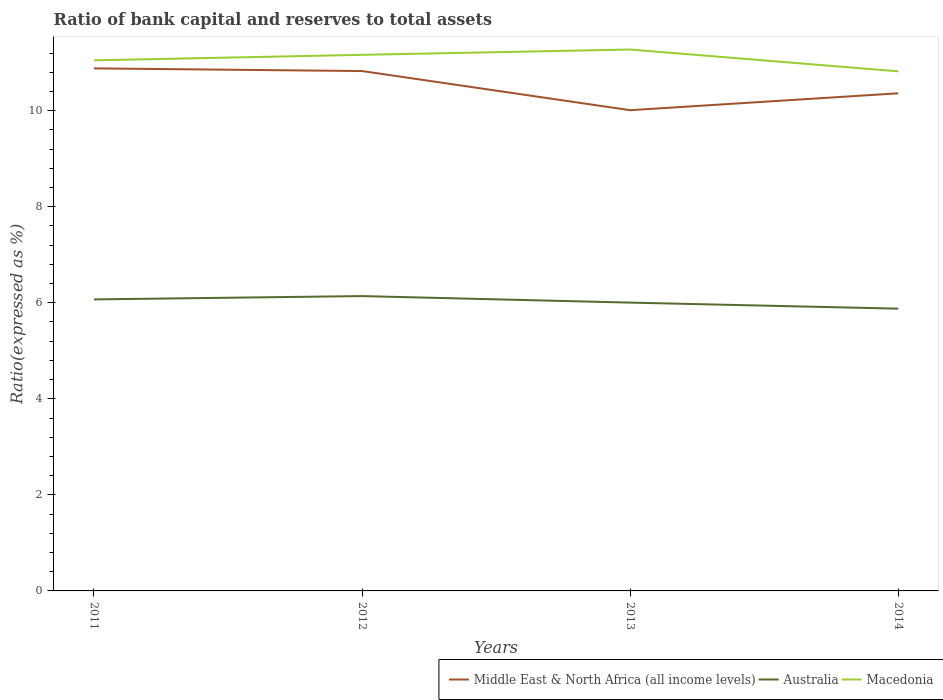How many different coloured lines are there?
Your answer should be compact. 3. Across all years, what is the maximum ratio of bank capital and reserves to total assets in Macedonia?
Offer a terse response. 10.82. In which year was the ratio of bank capital and reserves to total assets in Middle East & North Africa (all income levels) maximum?
Keep it short and to the point. 2013. What is the total ratio of bank capital and reserves to total assets in Australia in the graph?
Ensure brevity in your answer.  0.26. What is the difference between the highest and the second highest ratio of bank capital and reserves to total assets in Macedonia?
Keep it short and to the point. 0.45. How many lines are there?
Your answer should be compact. 3. How many years are there in the graph?
Ensure brevity in your answer.  4. What is the difference between two consecutive major ticks on the Y-axis?
Offer a terse response. 2. Where does the legend appear in the graph?
Ensure brevity in your answer.  Bottom right. How many legend labels are there?
Give a very brief answer. 3. How are the legend labels stacked?
Offer a terse response. Horizontal. What is the title of the graph?
Give a very brief answer. Ratio of bank capital and reserves to total assets. Does "Burundi" appear as one of the legend labels in the graph?
Your response must be concise. No. What is the label or title of the Y-axis?
Your response must be concise. Ratio(expressed as %). What is the Ratio(expressed as %) of Middle East & North Africa (all income levels) in 2011?
Provide a succinct answer. 10.88. What is the Ratio(expressed as %) of Australia in 2011?
Give a very brief answer. 6.07. What is the Ratio(expressed as %) of Macedonia in 2011?
Ensure brevity in your answer.  11.05. What is the Ratio(expressed as %) of Middle East & North Africa (all income levels) in 2012?
Your answer should be compact. 10.83. What is the Ratio(expressed as %) in Australia in 2012?
Ensure brevity in your answer.  6.14. What is the Ratio(expressed as %) in Macedonia in 2012?
Your answer should be compact. 11.16. What is the Ratio(expressed as %) in Middle East & North Africa (all income levels) in 2013?
Your answer should be very brief. 10.01. What is the Ratio(expressed as %) of Australia in 2013?
Your answer should be very brief. 6. What is the Ratio(expressed as %) in Macedonia in 2013?
Your answer should be very brief. 11.27. What is the Ratio(expressed as %) in Middle East & North Africa (all income levels) in 2014?
Ensure brevity in your answer.  10.36. What is the Ratio(expressed as %) in Australia in 2014?
Make the answer very short. 5.88. What is the Ratio(expressed as %) of Macedonia in 2014?
Provide a short and direct response. 10.82. Across all years, what is the maximum Ratio(expressed as %) in Middle East & North Africa (all income levels)?
Give a very brief answer. 10.88. Across all years, what is the maximum Ratio(expressed as %) of Australia?
Ensure brevity in your answer.  6.14. Across all years, what is the maximum Ratio(expressed as %) in Macedonia?
Ensure brevity in your answer.  11.27. Across all years, what is the minimum Ratio(expressed as %) in Middle East & North Africa (all income levels)?
Keep it short and to the point. 10.01. Across all years, what is the minimum Ratio(expressed as %) of Australia?
Your response must be concise. 5.88. Across all years, what is the minimum Ratio(expressed as %) in Macedonia?
Give a very brief answer. 10.82. What is the total Ratio(expressed as %) of Middle East & North Africa (all income levels) in the graph?
Your answer should be very brief. 42.08. What is the total Ratio(expressed as %) of Australia in the graph?
Offer a very short reply. 24.09. What is the total Ratio(expressed as %) of Macedonia in the graph?
Offer a terse response. 44.31. What is the difference between the Ratio(expressed as %) in Middle East & North Africa (all income levels) in 2011 and that in 2012?
Provide a succinct answer. 0.06. What is the difference between the Ratio(expressed as %) in Australia in 2011 and that in 2012?
Your answer should be compact. -0.07. What is the difference between the Ratio(expressed as %) in Macedonia in 2011 and that in 2012?
Offer a terse response. -0.12. What is the difference between the Ratio(expressed as %) in Middle East & North Africa (all income levels) in 2011 and that in 2013?
Offer a very short reply. 0.87. What is the difference between the Ratio(expressed as %) of Australia in 2011 and that in 2013?
Offer a terse response. 0.07. What is the difference between the Ratio(expressed as %) of Macedonia in 2011 and that in 2013?
Make the answer very short. -0.23. What is the difference between the Ratio(expressed as %) in Middle East & North Africa (all income levels) in 2011 and that in 2014?
Offer a terse response. 0.52. What is the difference between the Ratio(expressed as %) of Australia in 2011 and that in 2014?
Provide a succinct answer. 0.19. What is the difference between the Ratio(expressed as %) in Macedonia in 2011 and that in 2014?
Provide a short and direct response. 0.23. What is the difference between the Ratio(expressed as %) of Middle East & North Africa (all income levels) in 2012 and that in 2013?
Your answer should be very brief. 0.82. What is the difference between the Ratio(expressed as %) of Australia in 2012 and that in 2013?
Provide a short and direct response. 0.14. What is the difference between the Ratio(expressed as %) in Macedonia in 2012 and that in 2013?
Make the answer very short. -0.11. What is the difference between the Ratio(expressed as %) of Middle East & North Africa (all income levels) in 2012 and that in 2014?
Provide a succinct answer. 0.46. What is the difference between the Ratio(expressed as %) of Australia in 2012 and that in 2014?
Your answer should be very brief. 0.26. What is the difference between the Ratio(expressed as %) in Macedonia in 2012 and that in 2014?
Keep it short and to the point. 0.34. What is the difference between the Ratio(expressed as %) in Middle East & North Africa (all income levels) in 2013 and that in 2014?
Provide a short and direct response. -0.35. What is the difference between the Ratio(expressed as %) of Australia in 2013 and that in 2014?
Your answer should be very brief. 0.13. What is the difference between the Ratio(expressed as %) in Macedonia in 2013 and that in 2014?
Your response must be concise. 0.45. What is the difference between the Ratio(expressed as %) of Middle East & North Africa (all income levels) in 2011 and the Ratio(expressed as %) of Australia in 2012?
Provide a succinct answer. 4.74. What is the difference between the Ratio(expressed as %) in Middle East & North Africa (all income levels) in 2011 and the Ratio(expressed as %) in Macedonia in 2012?
Keep it short and to the point. -0.28. What is the difference between the Ratio(expressed as %) of Australia in 2011 and the Ratio(expressed as %) of Macedonia in 2012?
Keep it short and to the point. -5.09. What is the difference between the Ratio(expressed as %) of Middle East & North Africa (all income levels) in 2011 and the Ratio(expressed as %) of Australia in 2013?
Give a very brief answer. 4.88. What is the difference between the Ratio(expressed as %) of Middle East & North Africa (all income levels) in 2011 and the Ratio(expressed as %) of Macedonia in 2013?
Your answer should be very brief. -0.39. What is the difference between the Ratio(expressed as %) in Australia in 2011 and the Ratio(expressed as %) in Macedonia in 2013?
Keep it short and to the point. -5.2. What is the difference between the Ratio(expressed as %) of Middle East & North Africa (all income levels) in 2011 and the Ratio(expressed as %) of Australia in 2014?
Make the answer very short. 5. What is the difference between the Ratio(expressed as %) of Middle East & North Africa (all income levels) in 2011 and the Ratio(expressed as %) of Macedonia in 2014?
Keep it short and to the point. 0.06. What is the difference between the Ratio(expressed as %) in Australia in 2011 and the Ratio(expressed as %) in Macedonia in 2014?
Make the answer very short. -4.75. What is the difference between the Ratio(expressed as %) of Middle East & North Africa (all income levels) in 2012 and the Ratio(expressed as %) of Australia in 2013?
Make the answer very short. 4.82. What is the difference between the Ratio(expressed as %) of Middle East & North Africa (all income levels) in 2012 and the Ratio(expressed as %) of Macedonia in 2013?
Give a very brief answer. -0.45. What is the difference between the Ratio(expressed as %) of Australia in 2012 and the Ratio(expressed as %) of Macedonia in 2013?
Provide a succinct answer. -5.13. What is the difference between the Ratio(expressed as %) of Middle East & North Africa (all income levels) in 2012 and the Ratio(expressed as %) of Australia in 2014?
Offer a terse response. 4.95. What is the difference between the Ratio(expressed as %) in Middle East & North Africa (all income levels) in 2012 and the Ratio(expressed as %) in Macedonia in 2014?
Provide a short and direct response. 0.01. What is the difference between the Ratio(expressed as %) in Australia in 2012 and the Ratio(expressed as %) in Macedonia in 2014?
Give a very brief answer. -4.68. What is the difference between the Ratio(expressed as %) of Middle East & North Africa (all income levels) in 2013 and the Ratio(expressed as %) of Australia in 2014?
Keep it short and to the point. 4.13. What is the difference between the Ratio(expressed as %) in Middle East & North Africa (all income levels) in 2013 and the Ratio(expressed as %) in Macedonia in 2014?
Offer a terse response. -0.81. What is the difference between the Ratio(expressed as %) in Australia in 2013 and the Ratio(expressed as %) in Macedonia in 2014?
Ensure brevity in your answer.  -4.82. What is the average Ratio(expressed as %) in Middle East & North Africa (all income levels) per year?
Keep it short and to the point. 10.52. What is the average Ratio(expressed as %) of Australia per year?
Your response must be concise. 6.02. What is the average Ratio(expressed as %) of Macedonia per year?
Offer a very short reply. 11.08. In the year 2011, what is the difference between the Ratio(expressed as %) in Middle East & North Africa (all income levels) and Ratio(expressed as %) in Australia?
Ensure brevity in your answer.  4.81. In the year 2011, what is the difference between the Ratio(expressed as %) of Middle East & North Africa (all income levels) and Ratio(expressed as %) of Macedonia?
Provide a short and direct response. -0.17. In the year 2011, what is the difference between the Ratio(expressed as %) of Australia and Ratio(expressed as %) of Macedonia?
Your response must be concise. -4.98. In the year 2012, what is the difference between the Ratio(expressed as %) in Middle East & North Africa (all income levels) and Ratio(expressed as %) in Australia?
Your response must be concise. 4.69. In the year 2012, what is the difference between the Ratio(expressed as %) in Middle East & North Africa (all income levels) and Ratio(expressed as %) in Macedonia?
Ensure brevity in your answer.  -0.34. In the year 2012, what is the difference between the Ratio(expressed as %) of Australia and Ratio(expressed as %) of Macedonia?
Offer a terse response. -5.02. In the year 2013, what is the difference between the Ratio(expressed as %) in Middle East & North Africa (all income levels) and Ratio(expressed as %) in Australia?
Make the answer very short. 4.01. In the year 2013, what is the difference between the Ratio(expressed as %) in Middle East & North Africa (all income levels) and Ratio(expressed as %) in Macedonia?
Give a very brief answer. -1.26. In the year 2013, what is the difference between the Ratio(expressed as %) of Australia and Ratio(expressed as %) of Macedonia?
Keep it short and to the point. -5.27. In the year 2014, what is the difference between the Ratio(expressed as %) in Middle East & North Africa (all income levels) and Ratio(expressed as %) in Australia?
Your response must be concise. 4.48. In the year 2014, what is the difference between the Ratio(expressed as %) of Middle East & North Africa (all income levels) and Ratio(expressed as %) of Macedonia?
Give a very brief answer. -0.46. In the year 2014, what is the difference between the Ratio(expressed as %) of Australia and Ratio(expressed as %) of Macedonia?
Give a very brief answer. -4.94. What is the ratio of the Ratio(expressed as %) in Middle East & North Africa (all income levels) in 2011 to that in 2012?
Provide a succinct answer. 1.01. What is the ratio of the Ratio(expressed as %) in Australia in 2011 to that in 2012?
Ensure brevity in your answer.  0.99. What is the ratio of the Ratio(expressed as %) of Macedonia in 2011 to that in 2012?
Make the answer very short. 0.99. What is the ratio of the Ratio(expressed as %) in Middle East & North Africa (all income levels) in 2011 to that in 2013?
Offer a very short reply. 1.09. What is the ratio of the Ratio(expressed as %) in Australia in 2011 to that in 2013?
Provide a succinct answer. 1.01. What is the ratio of the Ratio(expressed as %) of Middle East & North Africa (all income levels) in 2011 to that in 2014?
Keep it short and to the point. 1.05. What is the ratio of the Ratio(expressed as %) of Australia in 2011 to that in 2014?
Offer a terse response. 1.03. What is the ratio of the Ratio(expressed as %) in Macedonia in 2011 to that in 2014?
Your answer should be very brief. 1.02. What is the ratio of the Ratio(expressed as %) in Middle East & North Africa (all income levels) in 2012 to that in 2013?
Make the answer very short. 1.08. What is the ratio of the Ratio(expressed as %) of Australia in 2012 to that in 2013?
Your answer should be very brief. 1.02. What is the ratio of the Ratio(expressed as %) of Macedonia in 2012 to that in 2013?
Your response must be concise. 0.99. What is the ratio of the Ratio(expressed as %) of Middle East & North Africa (all income levels) in 2012 to that in 2014?
Offer a terse response. 1.04. What is the ratio of the Ratio(expressed as %) in Australia in 2012 to that in 2014?
Your answer should be very brief. 1.04. What is the ratio of the Ratio(expressed as %) in Macedonia in 2012 to that in 2014?
Keep it short and to the point. 1.03. What is the ratio of the Ratio(expressed as %) of Middle East & North Africa (all income levels) in 2013 to that in 2014?
Keep it short and to the point. 0.97. What is the ratio of the Ratio(expressed as %) of Australia in 2013 to that in 2014?
Provide a short and direct response. 1.02. What is the ratio of the Ratio(expressed as %) in Macedonia in 2013 to that in 2014?
Give a very brief answer. 1.04. What is the difference between the highest and the second highest Ratio(expressed as %) in Middle East & North Africa (all income levels)?
Your response must be concise. 0.06. What is the difference between the highest and the second highest Ratio(expressed as %) in Australia?
Your answer should be compact. 0.07. What is the difference between the highest and the second highest Ratio(expressed as %) in Macedonia?
Provide a succinct answer. 0.11. What is the difference between the highest and the lowest Ratio(expressed as %) in Middle East & North Africa (all income levels)?
Provide a short and direct response. 0.87. What is the difference between the highest and the lowest Ratio(expressed as %) in Australia?
Your answer should be compact. 0.26. What is the difference between the highest and the lowest Ratio(expressed as %) of Macedonia?
Provide a short and direct response. 0.45. 